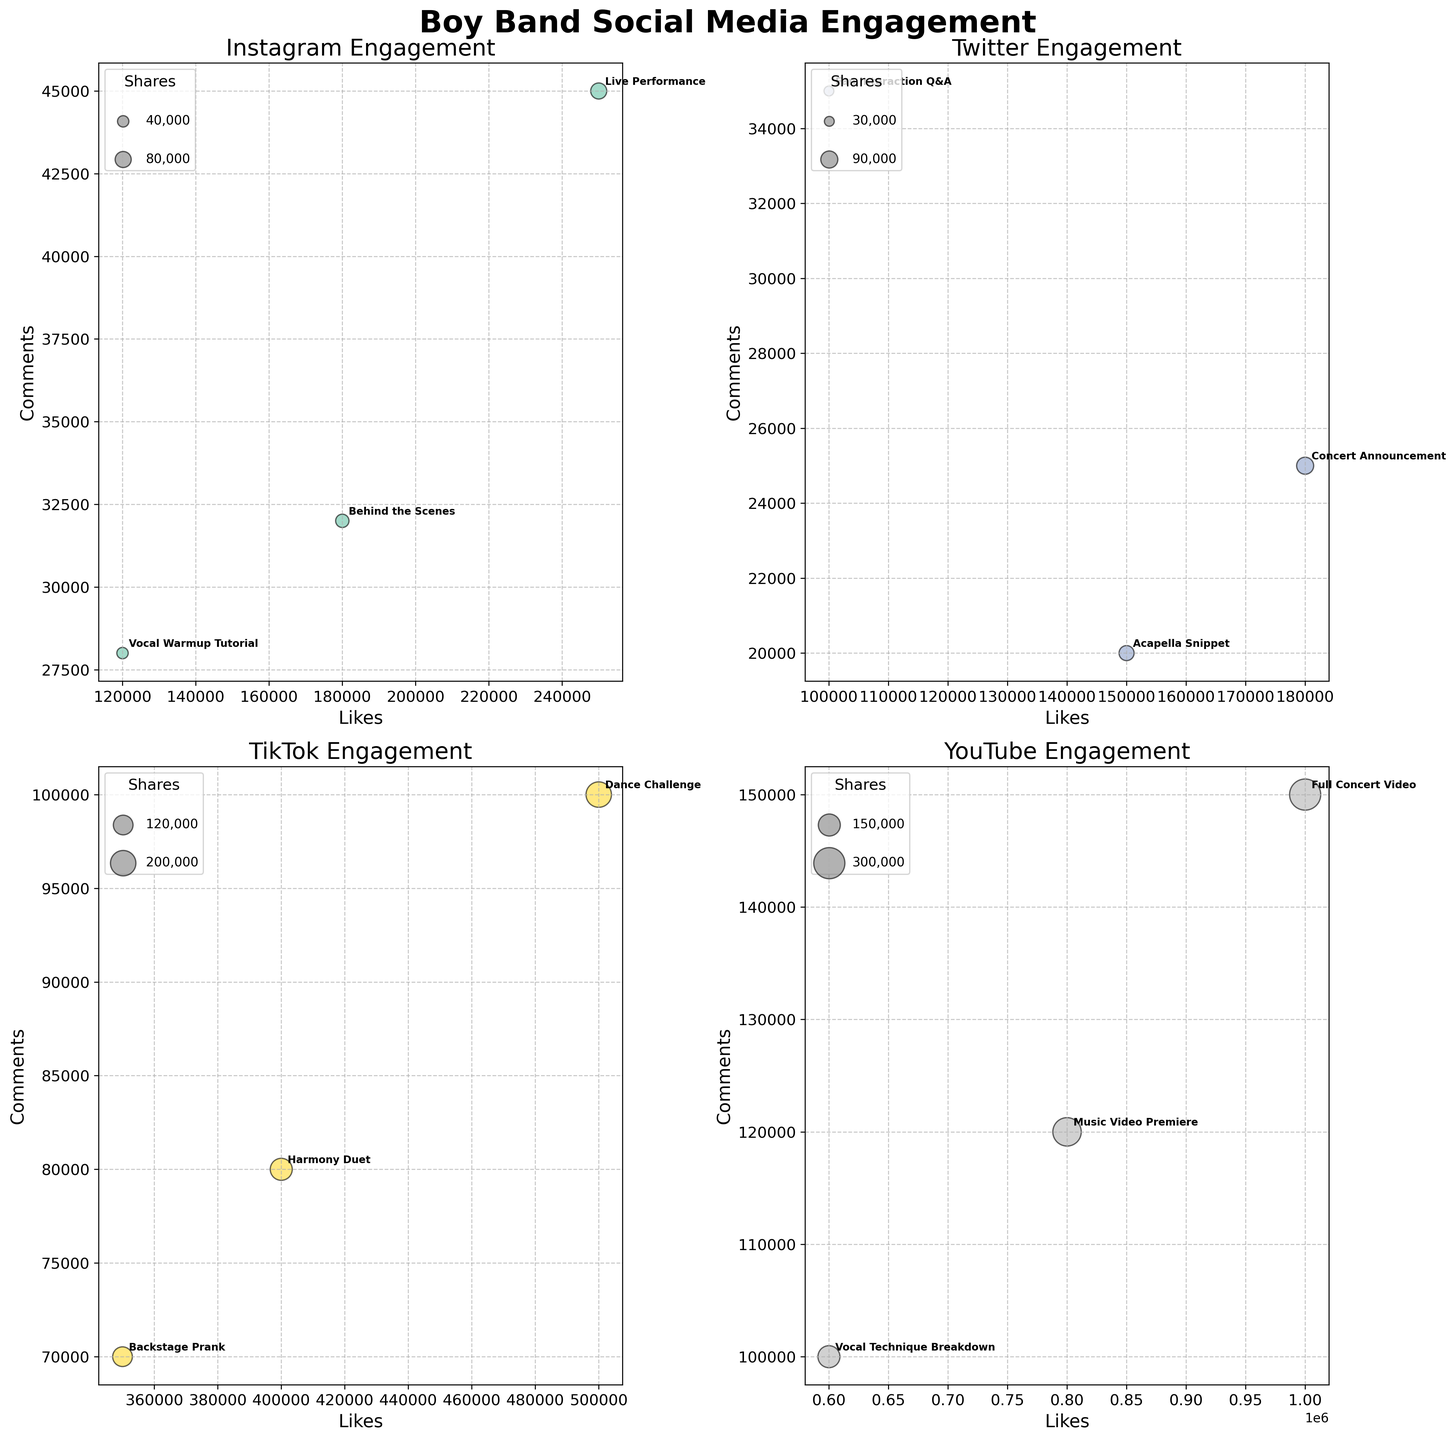What's the title of the figure? The title is usually at the top of the figure, written in larger or bold font for easy identification. Here, the title reads "Boy Band Social Media Engagement".
Answer: Boy Band Social Media Engagement Which platform has the highest number of Likes for any content type? By looking at the bubble chart with the highest horizontal position, YouTube's "Full Concert Video" has the most Likes, positioned at 1,000,000.
Answer: YouTube What is the average number of comments for content types on Instagram? On the Instagram subplot, the comments for each content type are as follows: Live Performance (45,000), Behind the Scenes (32,000), and Vocal Warmup Tutorial (28,000). Sum these values and divide by 3 to find the average: (45,000 + 32,000 + 28,000) / 3 = 35,000.
Answer: 35,000 Which content type on TikTok has more shares: Dance Challenge or Harmony Duet? Looking at the TikTok subplot, the Dance Challenge's bubble is the largest, representing 200,000 shares, while the Harmony Duet's size corresponds to 150,000 shares. Hence, Dance Challenge has more shares.
Answer: Dance Challenge Compare the total engagements for Vocal Technique Breakdown on YouTube and Fan Interaction Q&A on Twitter. Which one is larger and by how much? On the YouTube subplot, Vocal Technique Breakdown has total engagements of 850,000. On the Twitter subplot, Fan Interaction Q&A involves 165,000. Subtract these numbers: 850,000 - 165,000 = 685,000. Vocal Technique Breakdown has 685,000 more engagements.
Answer: Vocal Technique Breakdown by 685,000 What's the largest value represented on the y-axis, and which content type does it correspond to? The y-axis represents the number of comments. The highest value appears on the YouTube subplot for "Full Concert Video" with 150,000 comments.
Answer: Full Concert Video (150,000 Comments) How many content types are analyzed on the TikTok platform and what are they? The TikTok subplot shows three bubbles each labelled: Dance Challenge, Harmony Duet, and Backstage Prank. This indicates three content types.
Answer: Three: Dance Challenge, Harmony Duet, Backstage Prank Which content type on Twitter has the lowest number of comments? Examining the Twitter subplot, "Acapella Snippet" is marked at 20,000 comments, the lowest among Twitter content types.
Answer: Acapella Snippet What’s the average number of shares for the YouTube content types? On the YouTube subplot, the shares are as follows: Full Concert Video (300,000), Vocal Technique Breakdown (150,000), and Music Video Premiere (250,000). Sum these values and divide by 3 to find the average: (300,000 + 150,000 + 250,000) / 3 = 233,333.33.
Answer: 233,333.33 Which platform has the most engagement for the content type 'Vocal Warmup Tutorial' and what is the engagement value? The Vocal Warmup Tutorial shows up only on the Instagram subplot, with total engagements of 188,000, higher than any other engagement value for that content type across platforms.
Answer: Instagram (188,000) 